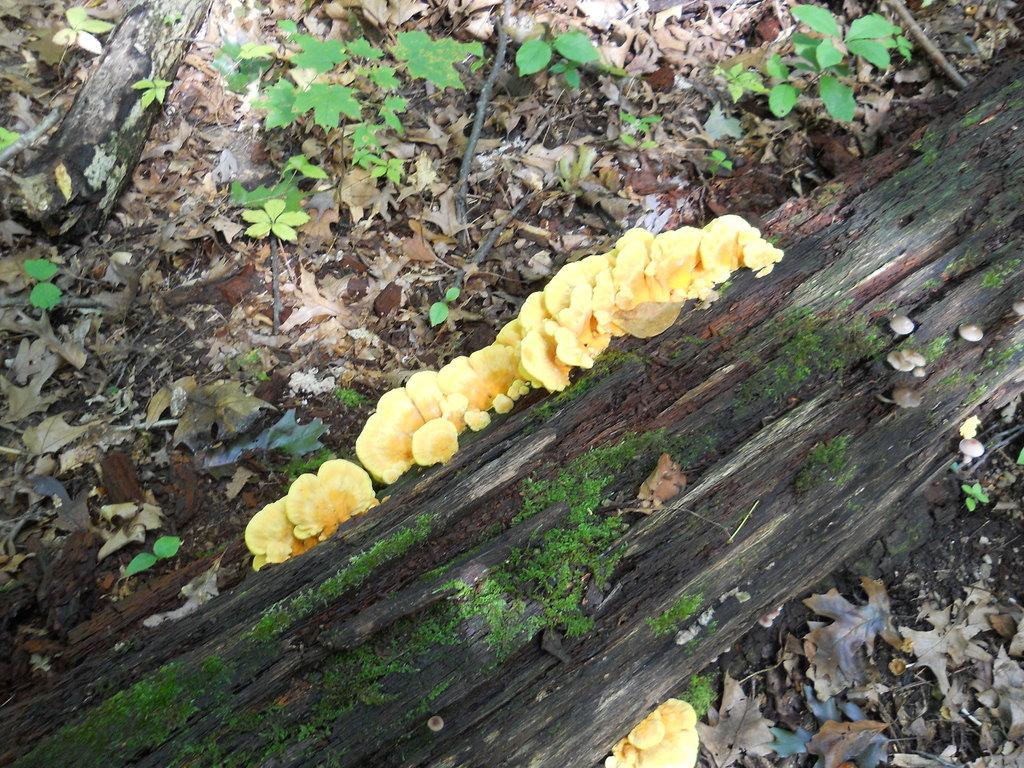What type of living organisms can be seen in the image? Plants can be seen in the image. What material is present in the image? Wood is present in the image. What can be found at the bottom of the image? Leaves are at the bottom of the image. What type of salt can be seen on the wood in the image? There is no salt present in the image; it only features plants, wood, and leaves. 